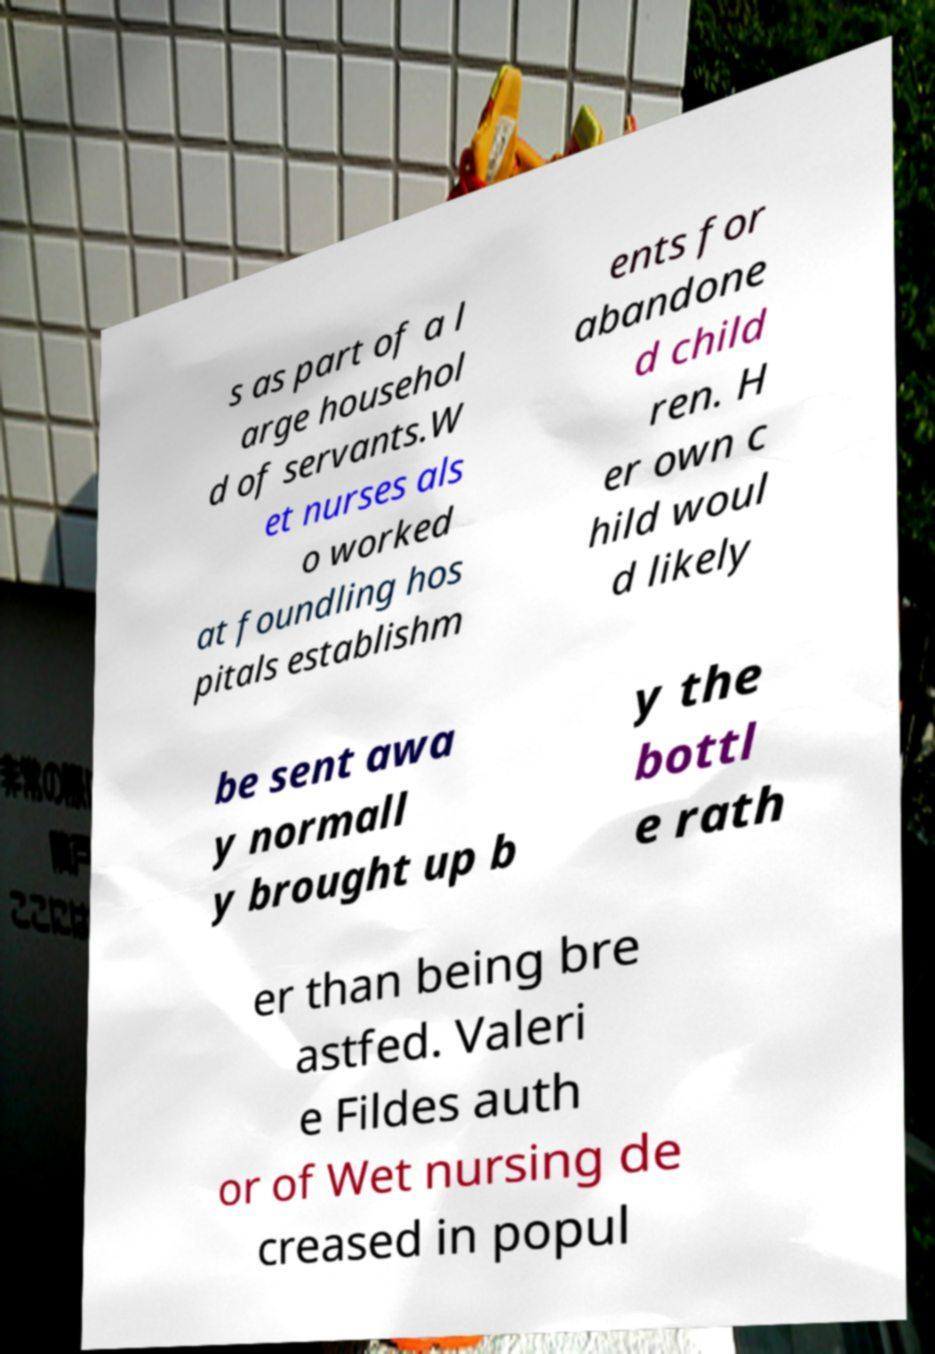Could you extract and type out the text from this image? s as part of a l arge househol d of servants.W et nurses als o worked at foundling hos pitals establishm ents for abandone d child ren. H er own c hild woul d likely be sent awa y normall y brought up b y the bottl e rath er than being bre astfed. Valeri e Fildes auth or of Wet nursing de creased in popul 